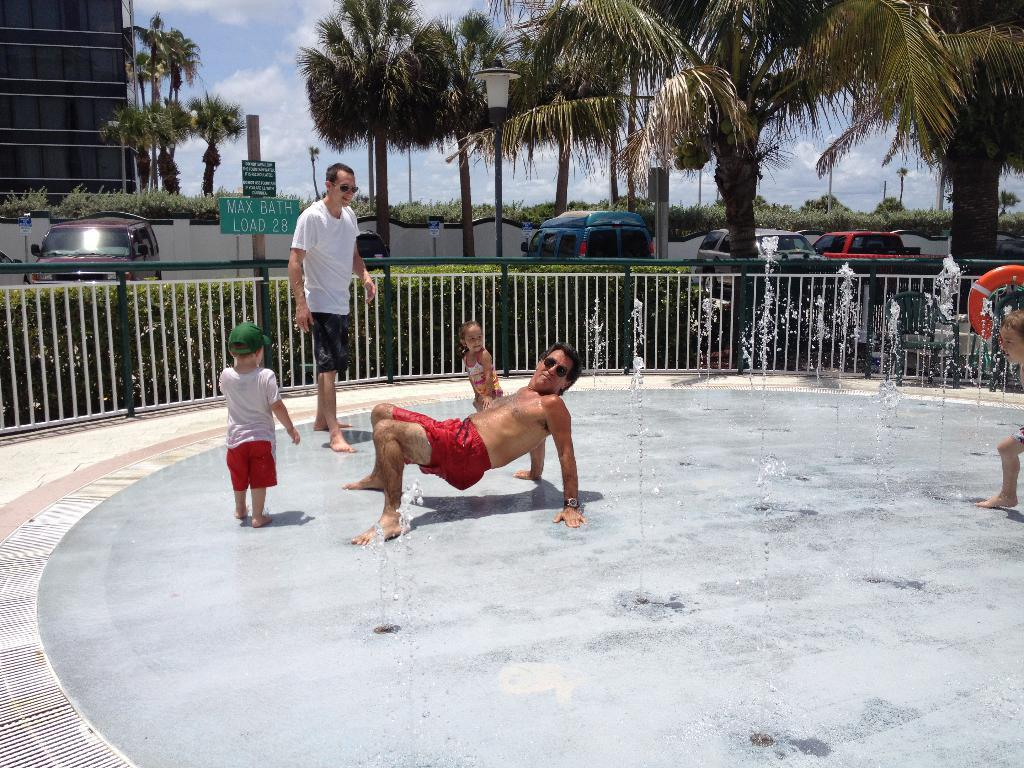What are the people in the image doing? The people in the image are on the floor. What can be seen in the background of the image? In the background of the image, there is a fence, cars, plants, and trees. What is visible at the top of the image? The sky is visible at the top of the image. Can you tell me how many books are being read by the beggar in the image? There is no beggar or books present in the image. 